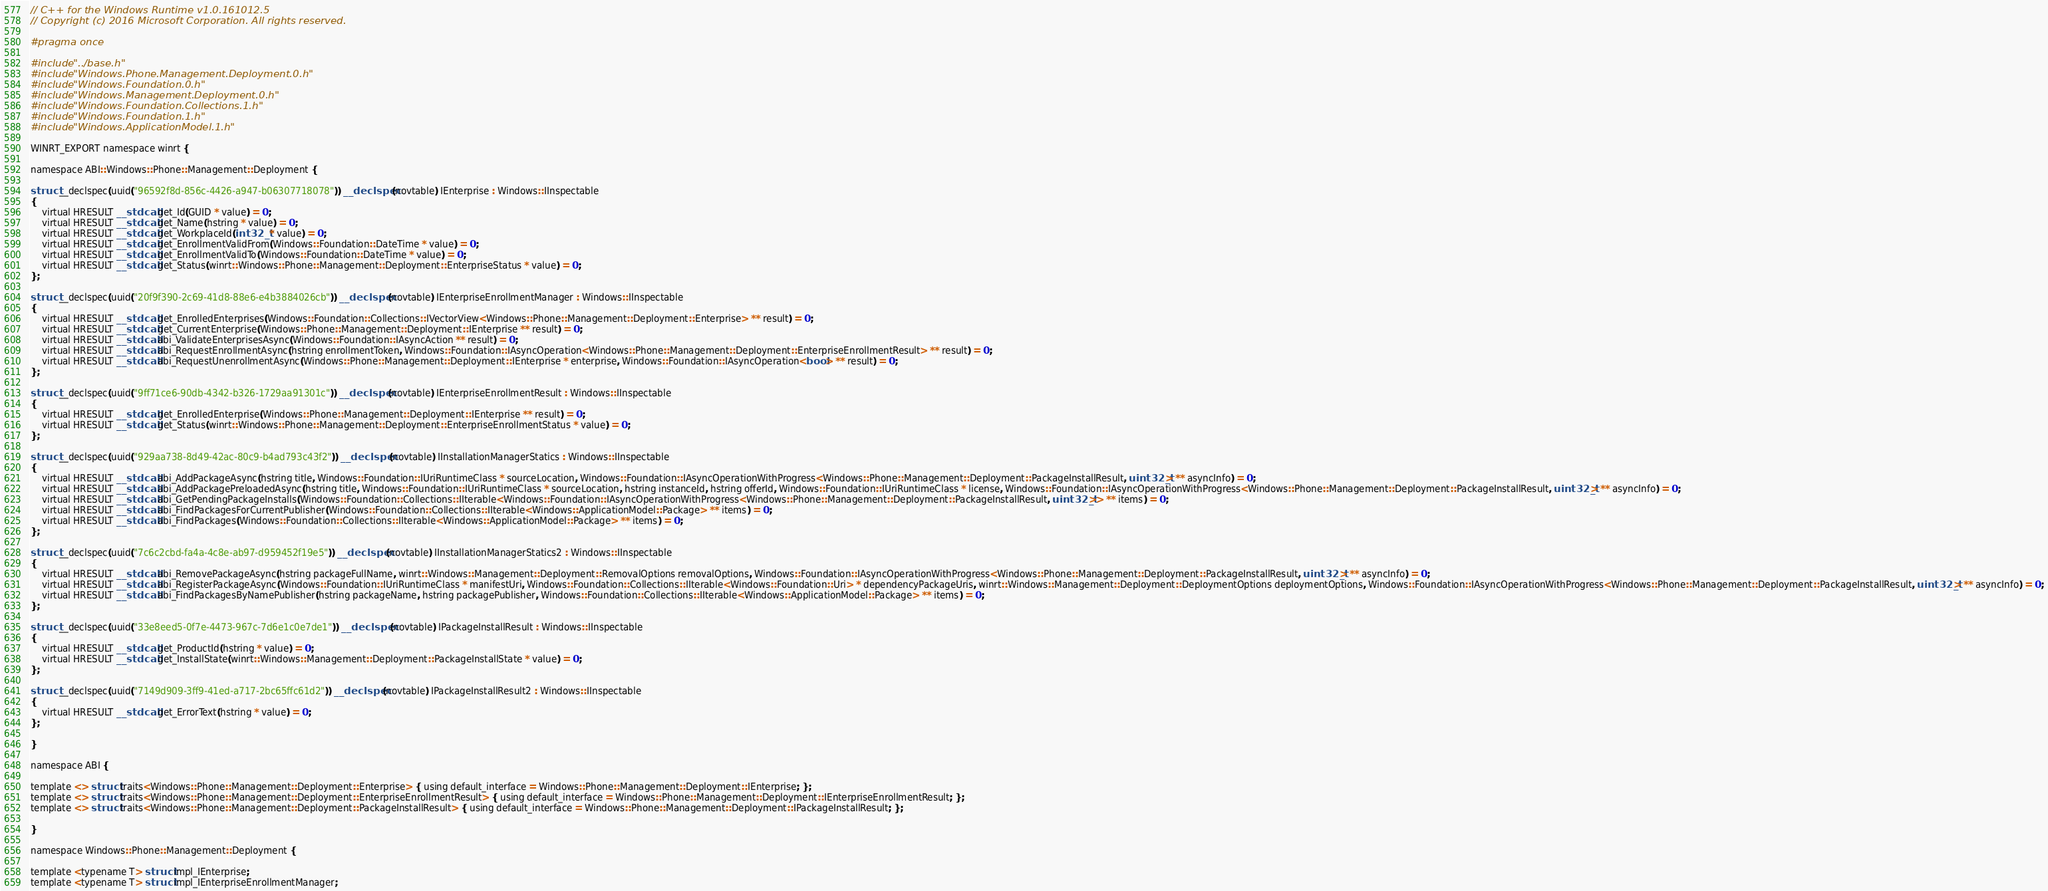Convert code to text. <code><loc_0><loc_0><loc_500><loc_500><_C_>// C++ for the Windows Runtime v1.0.161012.5
// Copyright (c) 2016 Microsoft Corporation. All rights reserved.

#pragma once

#include "../base.h"
#include "Windows.Phone.Management.Deployment.0.h"
#include "Windows.Foundation.0.h"
#include "Windows.Management.Deployment.0.h"
#include "Windows.Foundation.Collections.1.h"
#include "Windows.Foundation.1.h"
#include "Windows.ApplicationModel.1.h"

WINRT_EXPORT namespace winrt {

namespace ABI::Windows::Phone::Management::Deployment {

struct __declspec(uuid("96592f8d-856c-4426-a947-b06307718078")) __declspec(novtable) IEnterprise : Windows::IInspectable
{
    virtual HRESULT __stdcall get_Id(GUID * value) = 0;
    virtual HRESULT __stdcall get_Name(hstring * value) = 0;
    virtual HRESULT __stdcall get_WorkplaceId(int32_t * value) = 0;
    virtual HRESULT __stdcall get_EnrollmentValidFrom(Windows::Foundation::DateTime * value) = 0;
    virtual HRESULT __stdcall get_EnrollmentValidTo(Windows::Foundation::DateTime * value) = 0;
    virtual HRESULT __stdcall get_Status(winrt::Windows::Phone::Management::Deployment::EnterpriseStatus * value) = 0;
};

struct __declspec(uuid("20f9f390-2c69-41d8-88e6-e4b3884026cb")) __declspec(novtable) IEnterpriseEnrollmentManager : Windows::IInspectable
{
    virtual HRESULT __stdcall get_EnrolledEnterprises(Windows::Foundation::Collections::IVectorView<Windows::Phone::Management::Deployment::Enterprise> ** result) = 0;
    virtual HRESULT __stdcall get_CurrentEnterprise(Windows::Phone::Management::Deployment::IEnterprise ** result) = 0;
    virtual HRESULT __stdcall abi_ValidateEnterprisesAsync(Windows::Foundation::IAsyncAction ** result) = 0;
    virtual HRESULT __stdcall abi_RequestEnrollmentAsync(hstring enrollmentToken, Windows::Foundation::IAsyncOperation<Windows::Phone::Management::Deployment::EnterpriseEnrollmentResult> ** result) = 0;
    virtual HRESULT __stdcall abi_RequestUnenrollmentAsync(Windows::Phone::Management::Deployment::IEnterprise * enterprise, Windows::Foundation::IAsyncOperation<bool> ** result) = 0;
};

struct __declspec(uuid("9ff71ce6-90db-4342-b326-1729aa91301c")) __declspec(novtable) IEnterpriseEnrollmentResult : Windows::IInspectable
{
    virtual HRESULT __stdcall get_EnrolledEnterprise(Windows::Phone::Management::Deployment::IEnterprise ** result) = 0;
    virtual HRESULT __stdcall get_Status(winrt::Windows::Phone::Management::Deployment::EnterpriseEnrollmentStatus * value) = 0;
};

struct __declspec(uuid("929aa738-8d49-42ac-80c9-b4ad793c43f2")) __declspec(novtable) IInstallationManagerStatics : Windows::IInspectable
{
    virtual HRESULT __stdcall abi_AddPackageAsync(hstring title, Windows::Foundation::IUriRuntimeClass * sourceLocation, Windows::Foundation::IAsyncOperationWithProgress<Windows::Phone::Management::Deployment::PackageInstallResult, uint32_t> ** asyncInfo) = 0;
    virtual HRESULT __stdcall abi_AddPackagePreloadedAsync(hstring title, Windows::Foundation::IUriRuntimeClass * sourceLocation, hstring instanceId, hstring offerId, Windows::Foundation::IUriRuntimeClass * license, Windows::Foundation::IAsyncOperationWithProgress<Windows::Phone::Management::Deployment::PackageInstallResult, uint32_t> ** asyncInfo) = 0;
    virtual HRESULT __stdcall abi_GetPendingPackageInstalls(Windows::Foundation::Collections::IIterable<Windows::Foundation::IAsyncOperationWithProgress<Windows::Phone::Management::Deployment::PackageInstallResult, uint32_t>> ** items) = 0;
    virtual HRESULT __stdcall abi_FindPackagesForCurrentPublisher(Windows::Foundation::Collections::IIterable<Windows::ApplicationModel::Package> ** items) = 0;
    virtual HRESULT __stdcall abi_FindPackages(Windows::Foundation::Collections::IIterable<Windows::ApplicationModel::Package> ** items) = 0;
};

struct __declspec(uuid("7c6c2cbd-fa4a-4c8e-ab97-d959452f19e5")) __declspec(novtable) IInstallationManagerStatics2 : Windows::IInspectable
{
    virtual HRESULT __stdcall abi_RemovePackageAsync(hstring packageFullName, winrt::Windows::Management::Deployment::RemovalOptions removalOptions, Windows::Foundation::IAsyncOperationWithProgress<Windows::Phone::Management::Deployment::PackageInstallResult, uint32_t> ** asyncInfo) = 0;
    virtual HRESULT __stdcall abi_RegisterPackageAsync(Windows::Foundation::IUriRuntimeClass * manifestUri, Windows::Foundation::Collections::IIterable<Windows::Foundation::Uri> * dependencyPackageUris, winrt::Windows::Management::Deployment::DeploymentOptions deploymentOptions, Windows::Foundation::IAsyncOperationWithProgress<Windows::Phone::Management::Deployment::PackageInstallResult, uint32_t> ** asyncInfo) = 0;
    virtual HRESULT __stdcall abi_FindPackagesByNamePublisher(hstring packageName, hstring packagePublisher, Windows::Foundation::Collections::IIterable<Windows::ApplicationModel::Package> ** items) = 0;
};

struct __declspec(uuid("33e8eed5-0f7e-4473-967c-7d6e1c0e7de1")) __declspec(novtable) IPackageInstallResult : Windows::IInspectable
{
    virtual HRESULT __stdcall get_ProductId(hstring * value) = 0;
    virtual HRESULT __stdcall get_InstallState(winrt::Windows::Management::Deployment::PackageInstallState * value) = 0;
};

struct __declspec(uuid("7149d909-3ff9-41ed-a717-2bc65ffc61d2")) __declspec(novtable) IPackageInstallResult2 : Windows::IInspectable
{
    virtual HRESULT __stdcall get_ErrorText(hstring * value) = 0;
};

}

namespace ABI {

template <> struct traits<Windows::Phone::Management::Deployment::Enterprise> { using default_interface = Windows::Phone::Management::Deployment::IEnterprise; };
template <> struct traits<Windows::Phone::Management::Deployment::EnterpriseEnrollmentResult> { using default_interface = Windows::Phone::Management::Deployment::IEnterpriseEnrollmentResult; };
template <> struct traits<Windows::Phone::Management::Deployment::PackageInstallResult> { using default_interface = Windows::Phone::Management::Deployment::IPackageInstallResult; };

}

namespace Windows::Phone::Management::Deployment {

template <typename T> struct impl_IEnterprise;
template <typename T> struct impl_IEnterpriseEnrollmentManager;</code> 